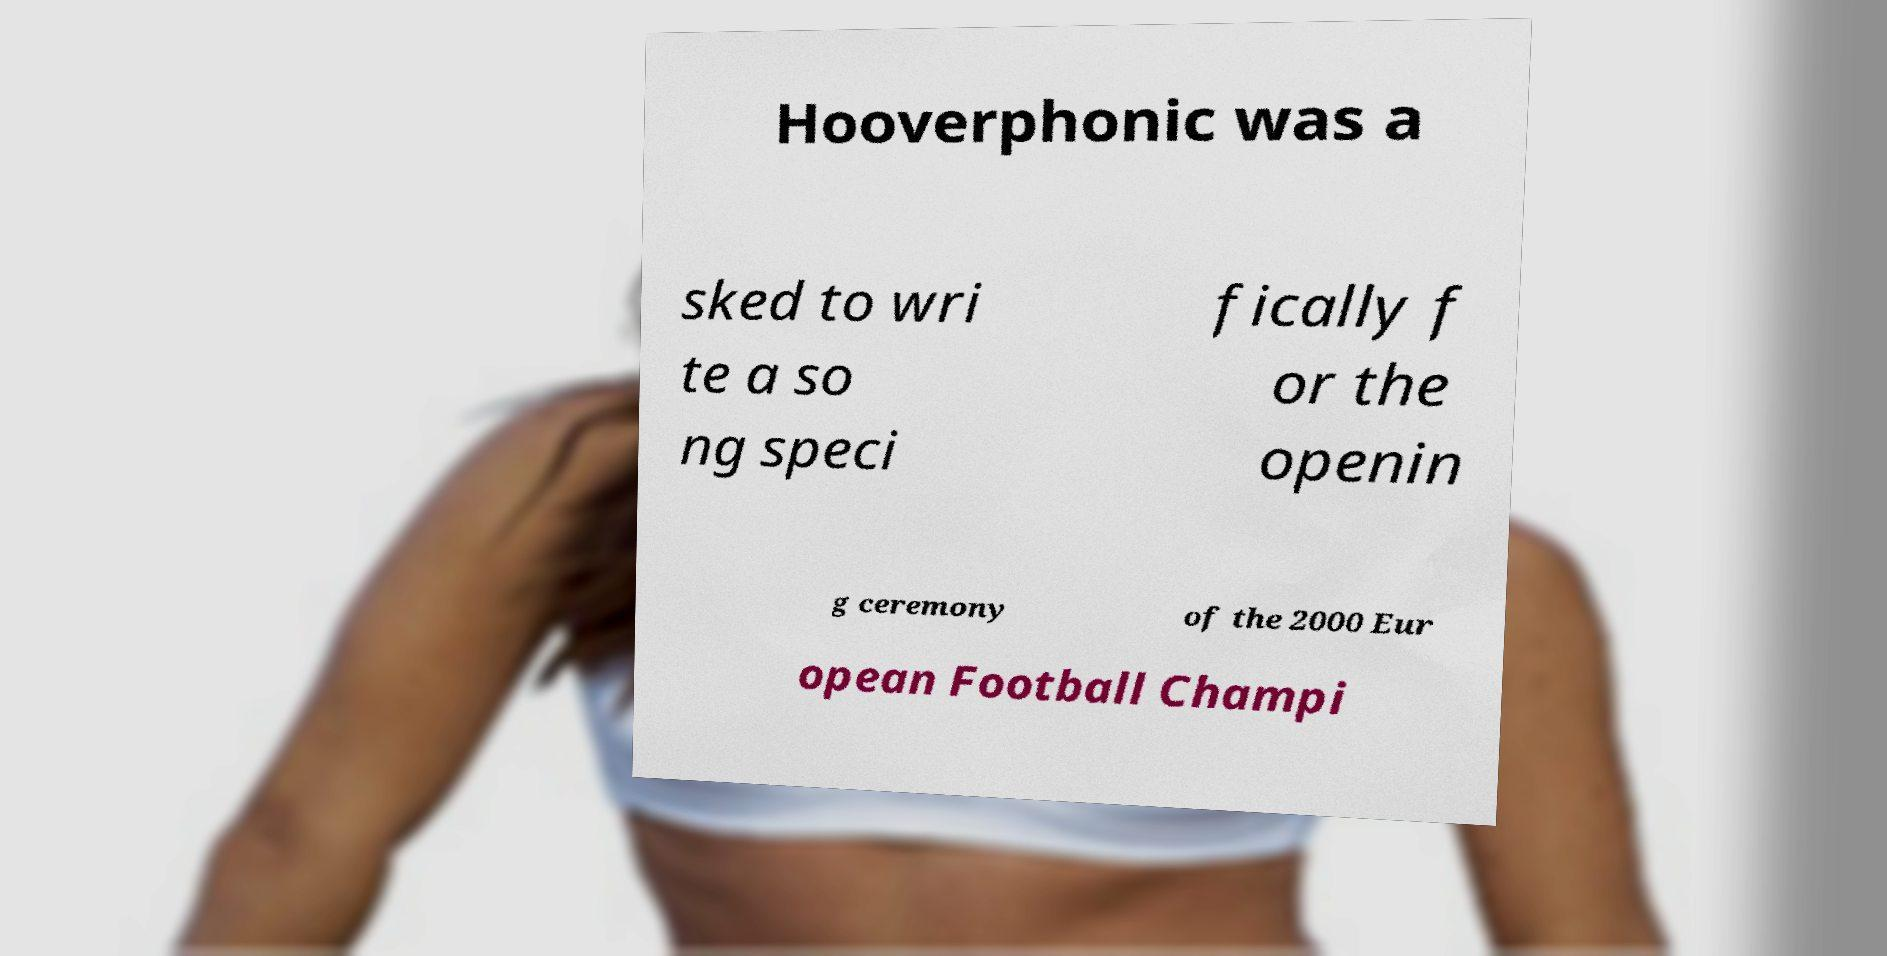Can you accurately transcribe the text from the provided image for me? Hooverphonic was a sked to wri te a so ng speci fically f or the openin g ceremony of the 2000 Eur opean Football Champi 